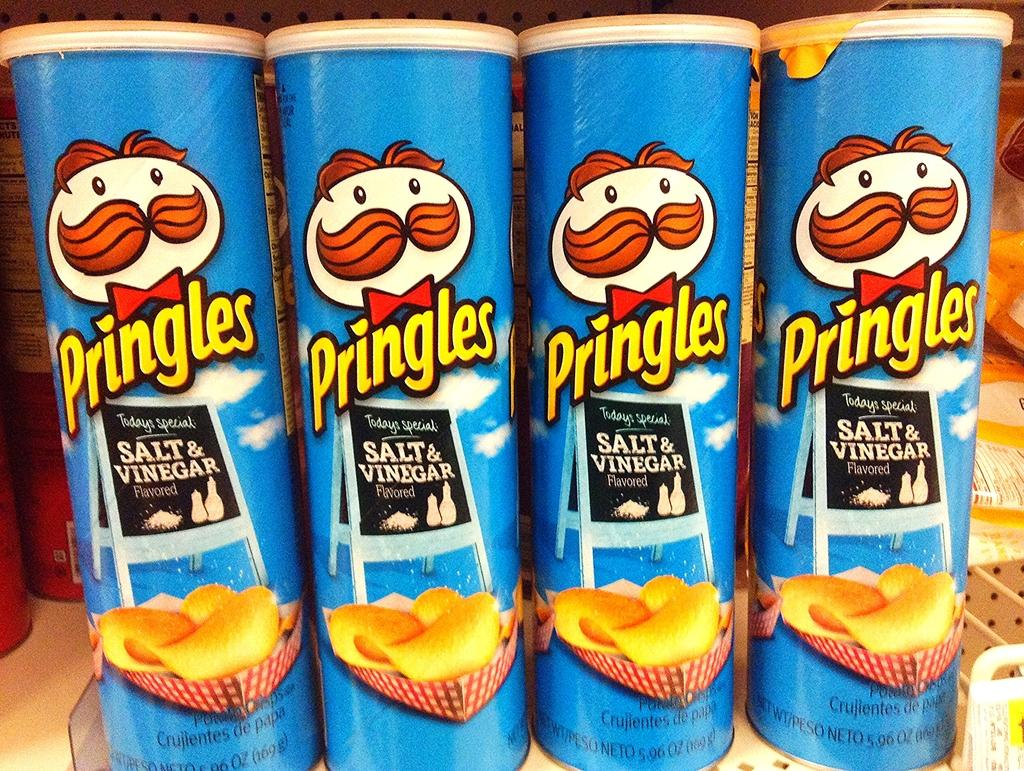What type of items can be seen in the image? There are food stock boxes in the image. Can you describe the contents of the boxes? The contents of the boxes are not visible in the image. Are there any other objects or structures present in the image? The provided facts do not mention any other objects or structures. What type of sign is hanging from the mouth of the pail in the image? There is no pail or sign present in the image; it only contains food stock boxes. 